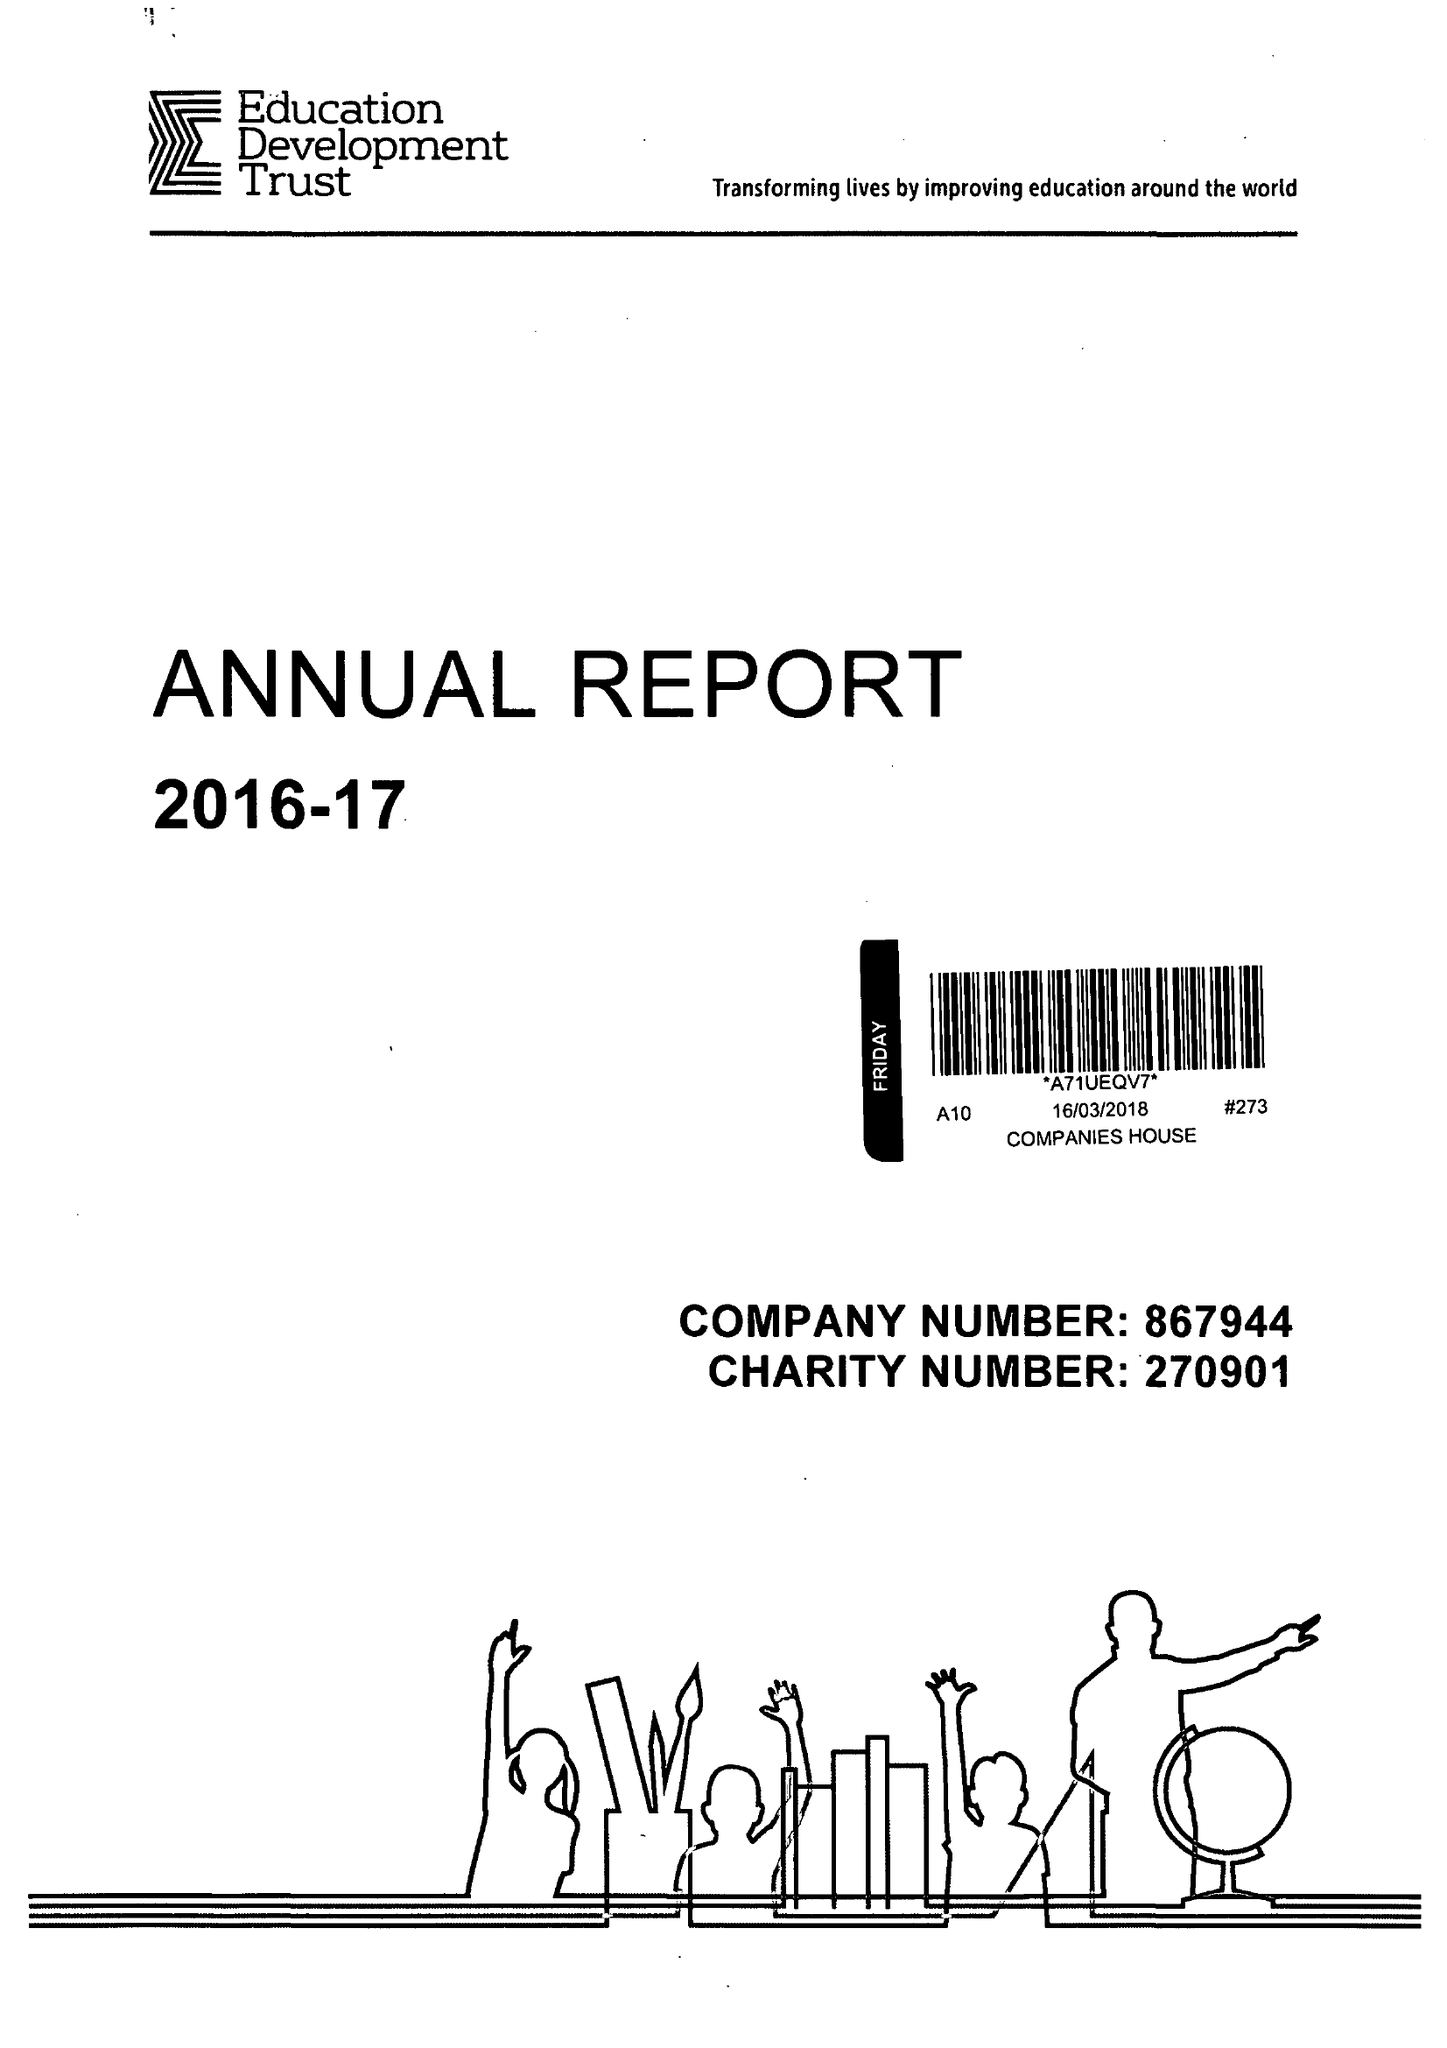What is the value for the charity_name?
Answer the question using a single word or phrase. Education Development Trust 